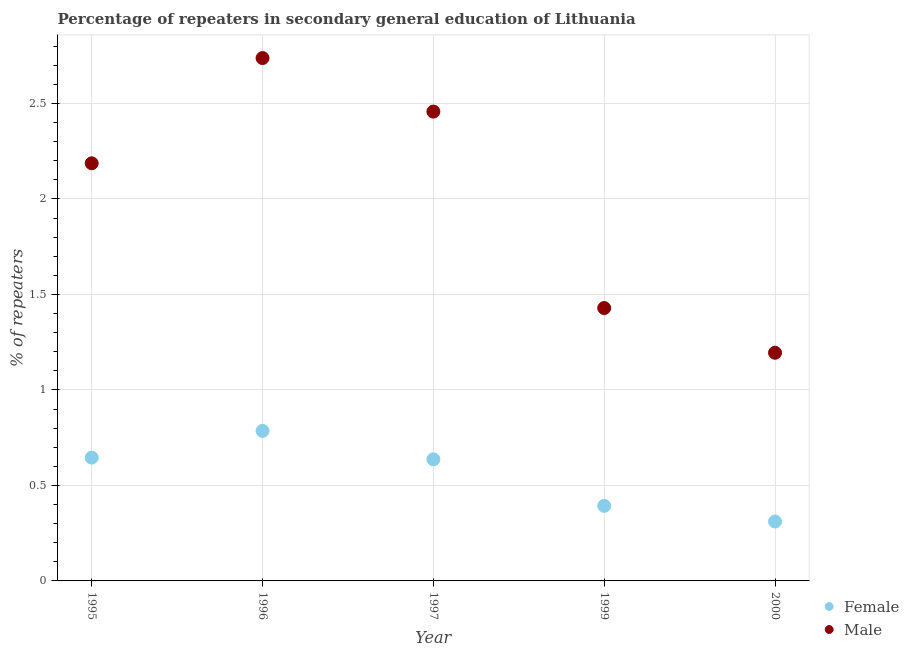How many different coloured dotlines are there?
Provide a succinct answer. 2. What is the percentage of male repeaters in 1997?
Ensure brevity in your answer.  2.46. Across all years, what is the maximum percentage of male repeaters?
Offer a terse response. 2.74. Across all years, what is the minimum percentage of male repeaters?
Provide a short and direct response. 1.19. In which year was the percentage of female repeaters maximum?
Your answer should be compact. 1996. What is the total percentage of male repeaters in the graph?
Offer a terse response. 10.01. What is the difference between the percentage of male repeaters in 1995 and that in 1996?
Make the answer very short. -0.55. What is the difference between the percentage of female repeaters in 1997 and the percentage of male repeaters in 2000?
Your response must be concise. -0.56. What is the average percentage of female repeaters per year?
Provide a succinct answer. 0.55. In the year 2000, what is the difference between the percentage of male repeaters and percentage of female repeaters?
Make the answer very short. 0.88. In how many years, is the percentage of female repeaters greater than 2.6 %?
Give a very brief answer. 0. What is the ratio of the percentage of male repeaters in 1999 to that in 2000?
Ensure brevity in your answer.  1.2. What is the difference between the highest and the second highest percentage of female repeaters?
Provide a short and direct response. 0.14. What is the difference between the highest and the lowest percentage of male repeaters?
Ensure brevity in your answer.  1.54. Is the percentage of male repeaters strictly greater than the percentage of female repeaters over the years?
Provide a succinct answer. Yes. How many dotlines are there?
Offer a terse response. 2. How many years are there in the graph?
Provide a succinct answer. 5. Are the values on the major ticks of Y-axis written in scientific E-notation?
Offer a very short reply. No. Does the graph contain any zero values?
Give a very brief answer. No. Does the graph contain grids?
Ensure brevity in your answer.  Yes. Where does the legend appear in the graph?
Ensure brevity in your answer.  Bottom right. How many legend labels are there?
Your response must be concise. 2. How are the legend labels stacked?
Your answer should be very brief. Vertical. What is the title of the graph?
Make the answer very short. Percentage of repeaters in secondary general education of Lithuania. Does "Passenger Transport Items" appear as one of the legend labels in the graph?
Keep it short and to the point. No. What is the label or title of the X-axis?
Offer a very short reply. Year. What is the label or title of the Y-axis?
Offer a terse response. % of repeaters. What is the % of repeaters of Female in 1995?
Offer a terse response. 0.65. What is the % of repeaters in Male in 1995?
Provide a succinct answer. 2.19. What is the % of repeaters of Female in 1996?
Keep it short and to the point. 0.79. What is the % of repeaters of Male in 1996?
Ensure brevity in your answer.  2.74. What is the % of repeaters in Female in 1997?
Provide a short and direct response. 0.64. What is the % of repeaters of Male in 1997?
Offer a terse response. 2.46. What is the % of repeaters in Female in 1999?
Offer a very short reply. 0.39. What is the % of repeaters of Male in 1999?
Offer a terse response. 1.43. What is the % of repeaters of Female in 2000?
Your response must be concise. 0.31. What is the % of repeaters of Male in 2000?
Offer a very short reply. 1.19. Across all years, what is the maximum % of repeaters in Female?
Keep it short and to the point. 0.79. Across all years, what is the maximum % of repeaters in Male?
Offer a terse response. 2.74. Across all years, what is the minimum % of repeaters of Female?
Make the answer very short. 0.31. Across all years, what is the minimum % of repeaters of Male?
Offer a terse response. 1.19. What is the total % of repeaters of Female in the graph?
Your answer should be very brief. 2.77. What is the total % of repeaters in Male in the graph?
Your response must be concise. 10.01. What is the difference between the % of repeaters of Female in 1995 and that in 1996?
Your answer should be very brief. -0.14. What is the difference between the % of repeaters of Male in 1995 and that in 1996?
Keep it short and to the point. -0.55. What is the difference between the % of repeaters of Female in 1995 and that in 1997?
Provide a succinct answer. 0.01. What is the difference between the % of repeaters of Male in 1995 and that in 1997?
Your answer should be compact. -0.27. What is the difference between the % of repeaters in Female in 1995 and that in 1999?
Make the answer very short. 0.25. What is the difference between the % of repeaters of Male in 1995 and that in 1999?
Ensure brevity in your answer.  0.76. What is the difference between the % of repeaters of Female in 1995 and that in 2000?
Make the answer very short. 0.33. What is the difference between the % of repeaters in Male in 1995 and that in 2000?
Your answer should be very brief. 0.99. What is the difference between the % of repeaters in Female in 1996 and that in 1997?
Offer a very short reply. 0.15. What is the difference between the % of repeaters in Male in 1996 and that in 1997?
Provide a succinct answer. 0.28. What is the difference between the % of repeaters of Female in 1996 and that in 1999?
Provide a short and direct response. 0.39. What is the difference between the % of repeaters of Male in 1996 and that in 1999?
Make the answer very short. 1.31. What is the difference between the % of repeaters in Female in 1996 and that in 2000?
Provide a short and direct response. 0.47. What is the difference between the % of repeaters of Male in 1996 and that in 2000?
Your response must be concise. 1.54. What is the difference between the % of repeaters in Female in 1997 and that in 1999?
Offer a terse response. 0.24. What is the difference between the % of repeaters in Male in 1997 and that in 1999?
Ensure brevity in your answer.  1.03. What is the difference between the % of repeaters of Female in 1997 and that in 2000?
Make the answer very short. 0.33. What is the difference between the % of repeaters in Male in 1997 and that in 2000?
Your answer should be compact. 1.26. What is the difference between the % of repeaters of Female in 1999 and that in 2000?
Ensure brevity in your answer.  0.08. What is the difference between the % of repeaters in Male in 1999 and that in 2000?
Give a very brief answer. 0.23. What is the difference between the % of repeaters in Female in 1995 and the % of repeaters in Male in 1996?
Keep it short and to the point. -2.09. What is the difference between the % of repeaters in Female in 1995 and the % of repeaters in Male in 1997?
Make the answer very short. -1.81. What is the difference between the % of repeaters in Female in 1995 and the % of repeaters in Male in 1999?
Keep it short and to the point. -0.78. What is the difference between the % of repeaters in Female in 1995 and the % of repeaters in Male in 2000?
Provide a succinct answer. -0.55. What is the difference between the % of repeaters in Female in 1996 and the % of repeaters in Male in 1997?
Offer a terse response. -1.67. What is the difference between the % of repeaters in Female in 1996 and the % of repeaters in Male in 1999?
Your answer should be compact. -0.64. What is the difference between the % of repeaters in Female in 1996 and the % of repeaters in Male in 2000?
Your response must be concise. -0.41. What is the difference between the % of repeaters of Female in 1997 and the % of repeaters of Male in 1999?
Offer a very short reply. -0.79. What is the difference between the % of repeaters of Female in 1997 and the % of repeaters of Male in 2000?
Make the answer very short. -0.56. What is the difference between the % of repeaters of Female in 1999 and the % of repeaters of Male in 2000?
Your answer should be very brief. -0.8. What is the average % of repeaters of Female per year?
Ensure brevity in your answer.  0.55. What is the average % of repeaters in Male per year?
Give a very brief answer. 2. In the year 1995, what is the difference between the % of repeaters of Female and % of repeaters of Male?
Your answer should be compact. -1.54. In the year 1996, what is the difference between the % of repeaters of Female and % of repeaters of Male?
Make the answer very short. -1.95. In the year 1997, what is the difference between the % of repeaters of Female and % of repeaters of Male?
Ensure brevity in your answer.  -1.82. In the year 1999, what is the difference between the % of repeaters of Female and % of repeaters of Male?
Offer a terse response. -1.04. In the year 2000, what is the difference between the % of repeaters in Female and % of repeaters in Male?
Your answer should be compact. -0.88. What is the ratio of the % of repeaters in Female in 1995 to that in 1996?
Offer a terse response. 0.82. What is the ratio of the % of repeaters in Male in 1995 to that in 1996?
Ensure brevity in your answer.  0.8. What is the ratio of the % of repeaters of Male in 1995 to that in 1997?
Your response must be concise. 0.89. What is the ratio of the % of repeaters in Female in 1995 to that in 1999?
Keep it short and to the point. 1.64. What is the ratio of the % of repeaters of Male in 1995 to that in 1999?
Your answer should be compact. 1.53. What is the ratio of the % of repeaters of Female in 1995 to that in 2000?
Offer a terse response. 2.08. What is the ratio of the % of repeaters in Male in 1995 to that in 2000?
Ensure brevity in your answer.  1.83. What is the ratio of the % of repeaters in Female in 1996 to that in 1997?
Give a very brief answer. 1.23. What is the ratio of the % of repeaters in Male in 1996 to that in 1997?
Provide a succinct answer. 1.11. What is the ratio of the % of repeaters of Female in 1996 to that in 1999?
Make the answer very short. 2. What is the ratio of the % of repeaters of Male in 1996 to that in 1999?
Offer a terse response. 1.92. What is the ratio of the % of repeaters of Female in 1996 to that in 2000?
Provide a succinct answer. 2.53. What is the ratio of the % of repeaters in Male in 1996 to that in 2000?
Your answer should be compact. 2.29. What is the ratio of the % of repeaters of Female in 1997 to that in 1999?
Your answer should be very brief. 1.62. What is the ratio of the % of repeaters of Male in 1997 to that in 1999?
Your response must be concise. 1.72. What is the ratio of the % of repeaters of Female in 1997 to that in 2000?
Give a very brief answer. 2.05. What is the ratio of the % of repeaters in Male in 1997 to that in 2000?
Offer a terse response. 2.06. What is the ratio of the % of repeaters in Female in 1999 to that in 2000?
Offer a terse response. 1.26. What is the ratio of the % of repeaters of Male in 1999 to that in 2000?
Make the answer very short. 1.2. What is the difference between the highest and the second highest % of repeaters of Female?
Make the answer very short. 0.14. What is the difference between the highest and the second highest % of repeaters of Male?
Provide a succinct answer. 0.28. What is the difference between the highest and the lowest % of repeaters in Female?
Ensure brevity in your answer.  0.47. What is the difference between the highest and the lowest % of repeaters of Male?
Your answer should be very brief. 1.54. 